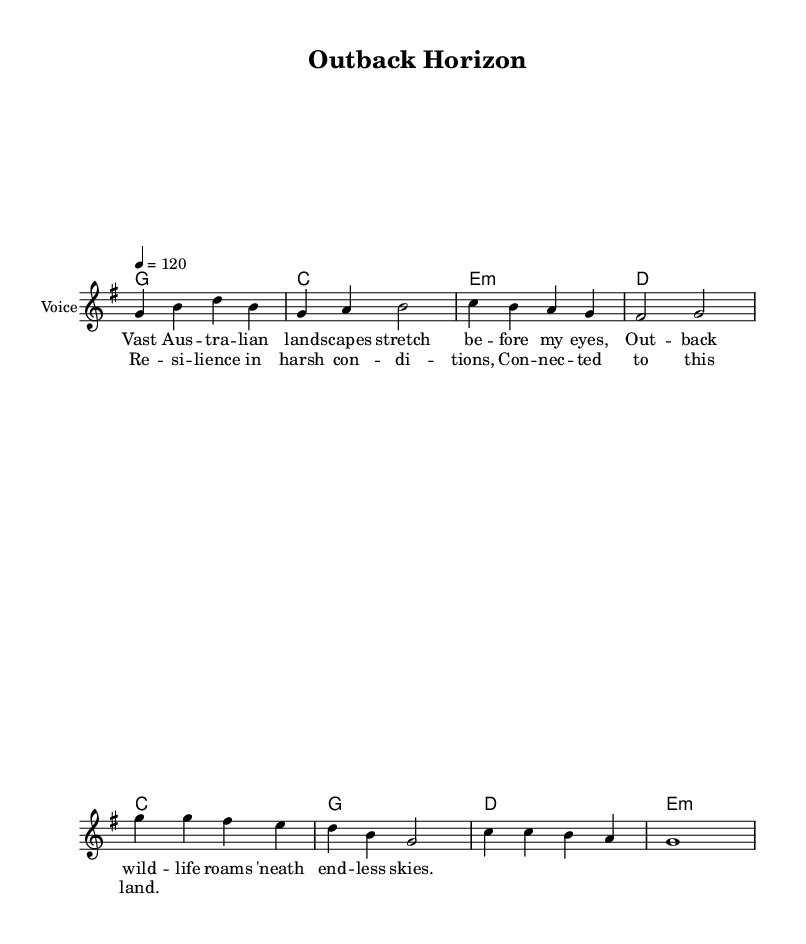What is the key signature of this music? The key signature indicates G major, which has one sharp (F#). This can be identified at the beginning of the sheet music, where the key signature is notated.
Answer: G major What is the time signature of this music? The time signature is 4/4, which is indicated at the beginning of the music. This means there are four beats in each measure and the quarter note receives one beat.
Answer: 4/4 What is the tempo marking of this music? The tempo is marked as quarter note equals 120, indicating a fast pace. This notation appears at the beginning of the score, detailing how quickly the piece should be played.
Answer: 120 How many measures are in the verse section? Counting the measures in the melody under the verse lyrics, there are four measures present before the chorus begins. Each measure is represented by vertical lines separating them.
Answer: 4 Which chord follows the "G" chord in the verse? The chord that follows the "G" chord in the verse is "C". This is identified by examining the chord progression laid out above the melody notes.
Answer: C What lyrical theme is present in the chorus? The theme in the chorus reflects resilience and connection to the land, as indicated by the lyrics provided for that section. This can be inferred from the words that emphasize the tough conditions and sentimentality towards the Australian landscape.
Answer: Resilience What is the final note of the melody in the chorus? The final note of the melody in the chorus is G, as indicated by the last note in that section of the sheet music. The melody line ends on this note, providing a sense of completion.
Answer: G 